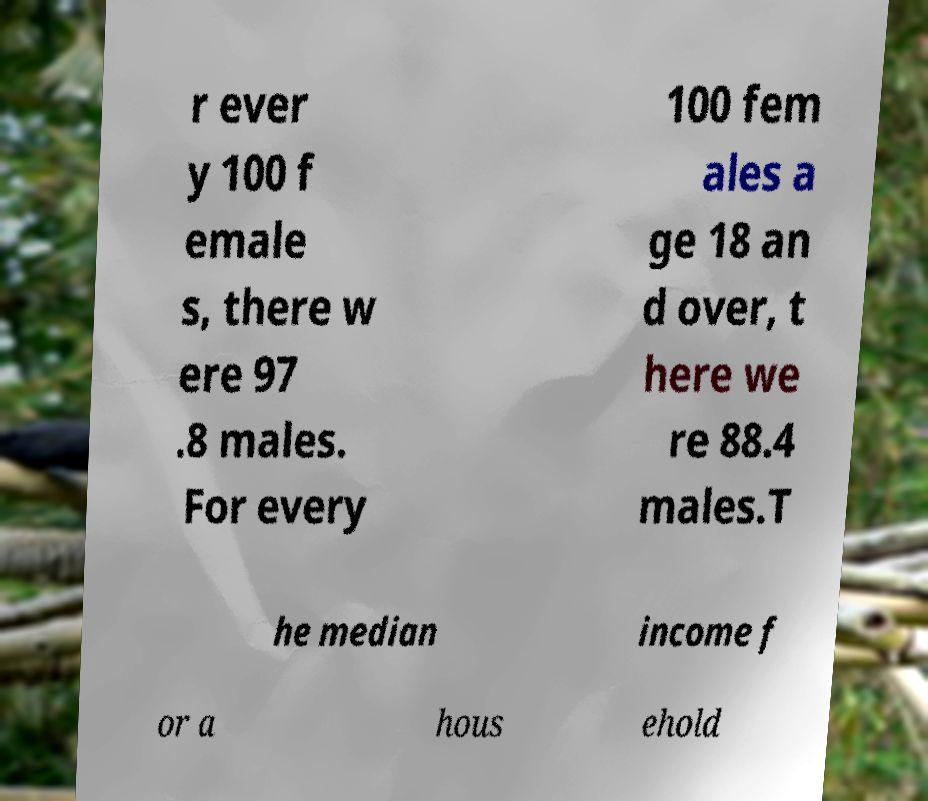Please read and relay the text visible in this image. What does it say? r ever y 100 f emale s, there w ere 97 .8 males. For every 100 fem ales a ge 18 an d over, t here we re 88.4 males.T he median income f or a hous ehold 